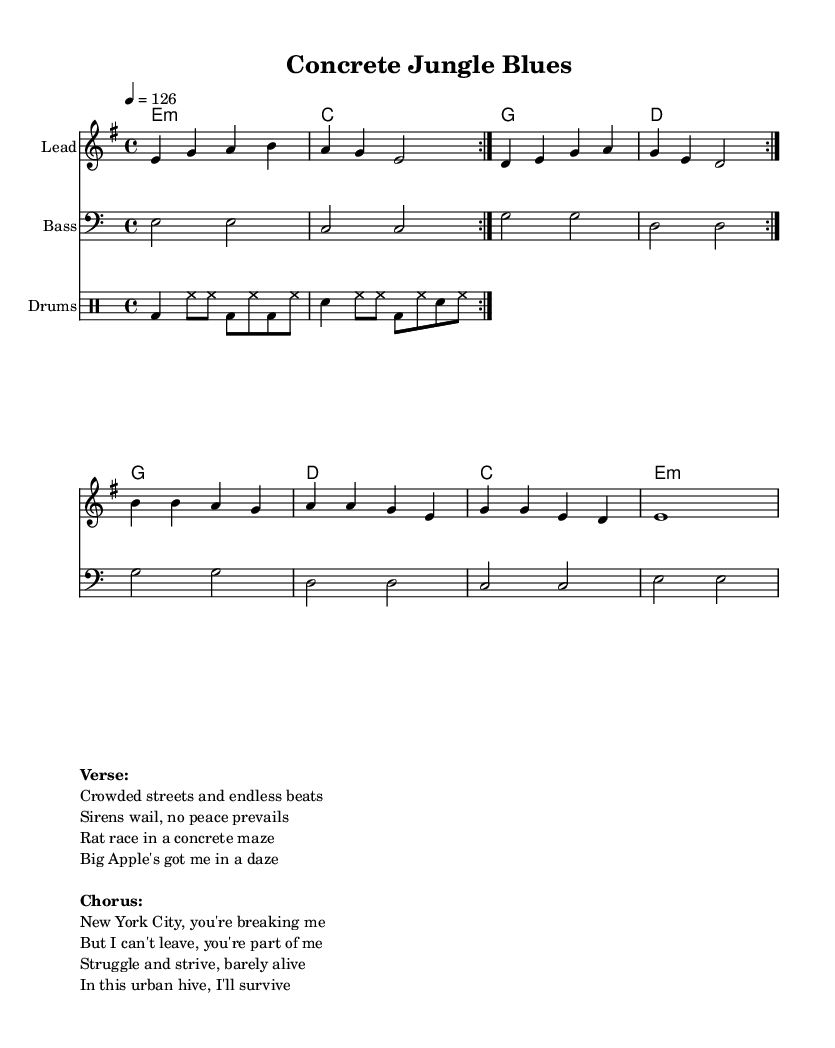What is the key signature of this music? The key signature is indicated by the first part of the staff, showing one sharp, which corresponds to E minor.
Answer: E minor What is the time signature of this music? The time signature is displayed on the left side of the staff, where it shows a "4/4" indicating four beats per measure.
Answer: 4/4 What is the tempo marking for this piece? The tempo is noted at the beginning with "4 = 126," indicating that the quarter note should be played at 126 beats per minute.
Answer: 126 How many measures are in the verse section? The verse is contained within the melody part, where we count eight measures highlighted by the repeated volta marking (which means to repeat the section).
Answer: 8 What chords accompany the chorus section? The chords are visible above the melody and are labeled for this part; they show E minor, C, G, and D, which allows for identifying the harmony during the chorus.
Answer: E minor, C, G, D What type of drum patterns are used in this piece? The drum patterns are categorized under "drummode" and show a rhythmic combination of bass drum, snare, and hi-hat, which is typical in rock music for creating a driving beat.
Answer: Bass, snare, hi-hat How does the main theme of the lyrics reflect New York City? The lyrics focus on "crowded streets", "sirens", and the "Big Apple," which evokes imagery of the hustle and bustle of city life.
Answer: Crowded streets, sirens, Big Apple 